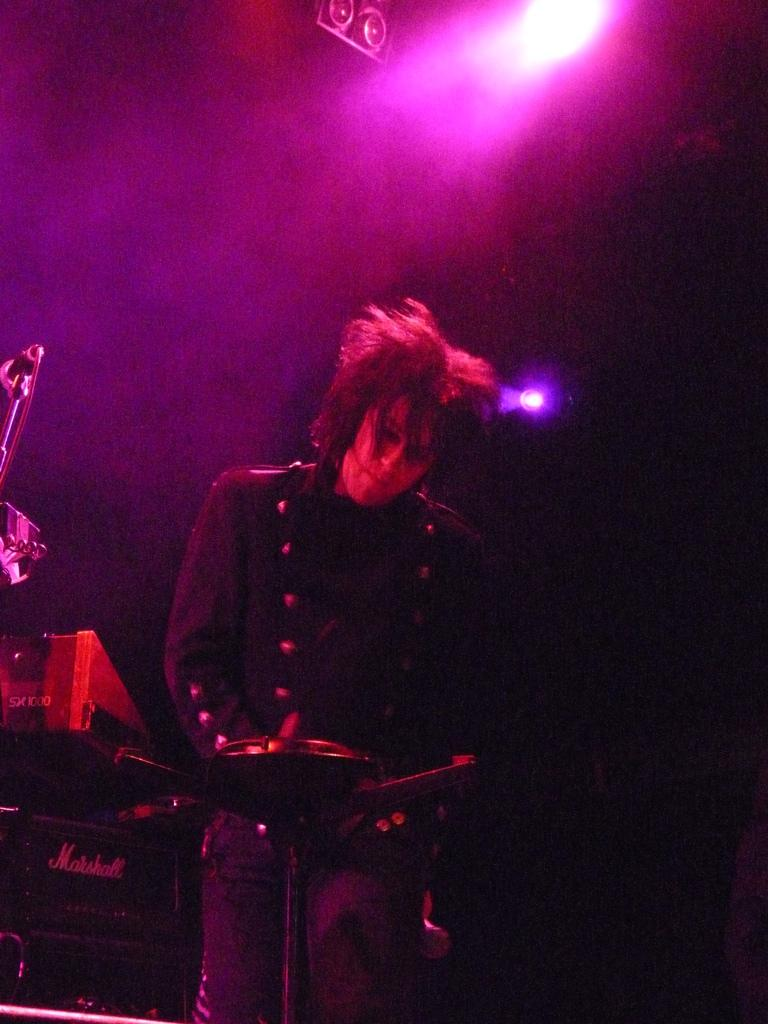What is the main subject of the image? There is a person standing in the image. What else can be seen in the image besides the person? There are objects visible in the image. How would you describe the overall lighting in the image? The background of the image is dark. What type of lighting is present in the background? Pink show lights are present in the background. What type of lettuce is being served to the pets in the image? There are no pets or lettuce present in the image. What error is visible in the image? There is no error visible in the image. 